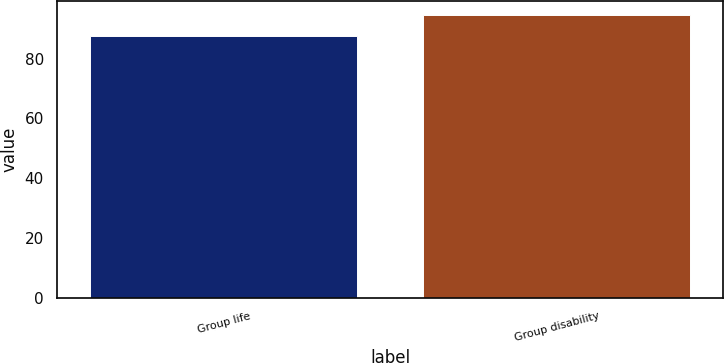Convert chart. <chart><loc_0><loc_0><loc_500><loc_500><bar_chart><fcel>Group life<fcel>Group disability<nl><fcel>87.5<fcel>94.6<nl></chart> 